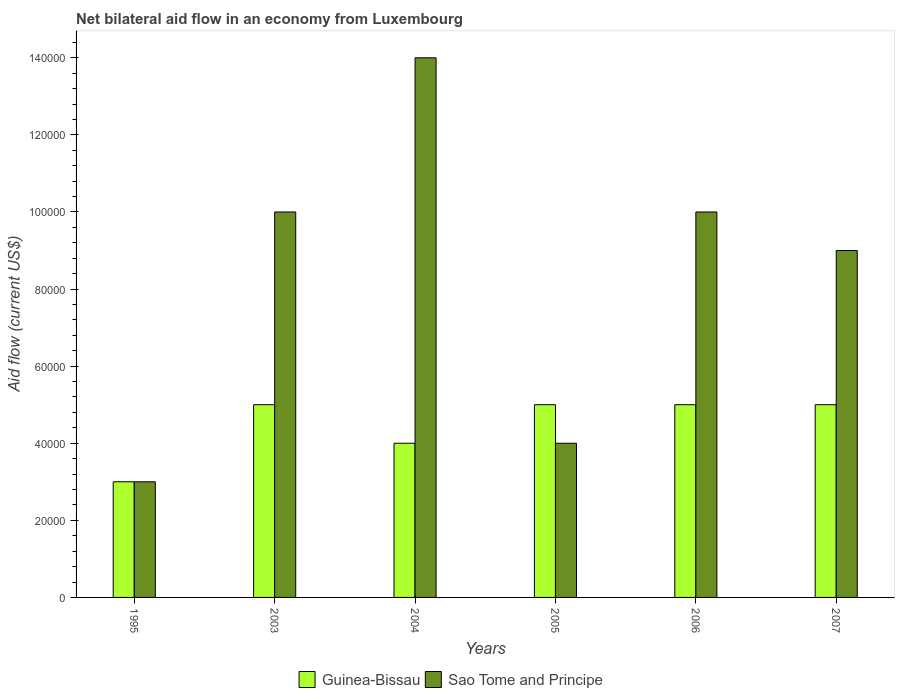How many different coloured bars are there?
Ensure brevity in your answer.  2. How many groups of bars are there?
Provide a short and direct response. 6. Are the number of bars per tick equal to the number of legend labels?
Provide a short and direct response. Yes. Are the number of bars on each tick of the X-axis equal?
Make the answer very short. Yes. How many bars are there on the 4th tick from the left?
Make the answer very short. 2. How many bars are there on the 6th tick from the right?
Give a very brief answer. 2. In how many cases, is the number of bars for a given year not equal to the number of legend labels?
Offer a terse response. 0. Across all years, what is the minimum net bilateral aid flow in Sao Tome and Principe?
Keep it short and to the point. 3.00e+04. In which year was the net bilateral aid flow in Guinea-Bissau maximum?
Provide a short and direct response. 2003. In which year was the net bilateral aid flow in Sao Tome and Principe minimum?
Give a very brief answer. 1995. What is the total net bilateral aid flow in Sao Tome and Principe in the graph?
Keep it short and to the point. 5.00e+05. What is the average net bilateral aid flow in Guinea-Bissau per year?
Your answer should be very brief. 4.50e+04. In how many years, is the net bilateral aid flow in Guinea-Bissau greater than 124000 US$?
Make the answer very short. 0. What is the ratio of the net bilateral aid flow in Guinea-Bissau in 2004 to that in 2006?
Keep it short and to the point. 0.8. What is the difference between the highest and the second highest net bilateral aid flow in Guinea-Bissau?
Offer a very short reply. 0. What does the 1st bar from the left in 2005 represents?
Make the answer very short. Guinea-Bissau. What does the 2nd bar from the right in 2003 represents?
Provide a succinct answer. Guinea-Bissau. How many bars are there?
Keep it short and to the point. 12. Are all the bars in the graph horizontal?
Provide a succinct answer. No. What is the difference between two consecutive major ticks on the Y-axis?
Give a very brief answer. 2.00e+04. Where does the legend appear in the graph?
Your answer should be compact. Bottom center. How many legend labels are there?
Provide a succinct answer. 2. What is the title of the graph?
Your answer should be compact. Net bilateral aid flow in an economy from Luxembourg. What is the Aid flow (current US$) of Guinea-Bissau in 2003?
Give a very brief answer. 5.00e+04. What is the Aid flow (current US$) of Guinea-Bissau in 2004?
Your response must be concise. 4.00e+04. What is the Aid flow (current US$) in Guinea-Bissau in 2006?
Provide a short and direct response. 5.00e+04. What is the Aid flow (current US$) of Sao Tome and Principe in 2006?
Provide a short and direct response. 1.00e+05. What is the difference between the Aid flow (current US$) in Guinea-Bissau in 1995 and that in 2003?
Provide a short and direct response. -2.00e+04. What is the difference between the Aid flow (current US$) in Guinea-Bissau in 1995 and that in 2004?
Offer a very short reply. -10000. What is the difference between the Aid flow (current US$) in Guinea-Bissau in 1995 and that in 2005?
Offer a very short reply. -2.00e+04. What is the difference between the Aid flow (current US$) in Sao Tome and Principe in 1995 and that in 2005?
Provide a succinct answer. -10000. What is the difference between the Aid flow (current US$) of Guinea-Bissau in 1995 and that in 2006?
Provide a short and direct response. -2.00e+04. What is the difference between the Aid flow (current US$) of Sao Tome and Principe in 2003 and that in 2004?
Make the answer very short. -4.00e+04. What is the difference between the Aid flow (current US$) in Sao Tome and Principe in 2003 and that in 2006?
Offer a terse response. 0. What is the difference between the Aid flow (current US$) in Guinea-Bissau in 2003 and that in 2007?
Provide a short and direct response. 0. What is the difference between the Aid flow (current US$) of Sao Tome and Principe in 2003 and that in 2007?
Ensure brevity in your answer.  10000. What is the difference between the Aid flow (current US$) of Guinea-Bissau in 2004 and that in 2006?
Provide a short and direct response. -10000. What is the difference between the Aid flow (current US$) of Sao Tome and Principe in 2004 and that in 2006?
Offer a very short reply. 4.00e+04. What is the difference between the Aid flow (current US$) of Sao Tome and Principe in 2004 and that in 2007?
Your answer should be very brief. 5.00e+04. What is the difference between the Aid flow (current US$) of Sao Tome and Principe in 2005 and that in 2006?
Provide a short and direct response. -6.00e+04. What is the difference between the Aid flow (current US$) of Sao Tome and Principe in 2005 and that in 2007?
Keep it short and to the point. -5.00e+04. What is the difference between the Aid flow (current US$) of Guinea-Bissau in 2006 and that in 2007?
Offer a terse response. 0. What is the difference between the Aid flow (current US$) in Guinea-Bissau in 1995 and the Aid flow (current US$) in Sao Tome and Principe in 2003?
Offer a terse response. -7.00e+04. What is the difference between the Aid flow (current US$) of Guinea-Bissau in 1995 and the Aid flow (current US$) of Sao Tome and Principe in 2004?
Ensure brevity in your answer.  -1.10e+05. What is the difference between the Aid flow (current US$) of Guinea-Bissau in 1995 and the Aid flow (current US$) of Sao Tome and Principe in 2005?
Your answer should be very brief. -10000. What is the difference between the Aid flow (current US$) in Guinea-Bissau in 1995 and the Aid flow (current US$) in Sao Tome and Principe in 2006?
Your answer should be very brief. -7.00e+04. What is the difference between the Aid flow (current US$) in Guinea-Bissau in 2003 and the Aid flow (current US$) in Sao Tome and Principe in 2004?
Keep it short and to the point. -9.00e+04. What is the difference between the Aid flow (current US$) of Guinea-Bissau in 2003 and the Aid flow (current US$) of Sao Tome and Principe in 2007?
Ensure brevity in your answer.  -4.00e+04. What is the difference between the Aid flow (current US$) of Guinea-Bissau in 2004 and the Aid flow (current US$) of Sao Tome and Principe in 2005?
Your answer should be very brief. 0. What is the difference between the Aid flow (current US$) in Guinea-Bissau in 2006 and the Aid flow (current US$) in Sao Tome and Principe in 2007?
Make the answer very short. -4.00e+04. What is the average Aid flow (current US$) in Guinea-Bissau per year?
Your answer should be compact. 4.50e+04. What is the average Aid flow (current US$) of Sao Tome and Principe per year?
Make the answer very short. 8.33e+04. In the year 1995, what is the difference between the Aid flow (current US$) in Guinea-Bissau and Aid flow (current US$) in Sao Tome and Principe?
Provide a short and direct response. 0. In the year 2003, what is the difference between the Aid flow (current US$) of Guinea-Bissau and Aid flow (current US$) of Sao Tome and Principe?
Provide a short and direct response. -5.00e+04. In the year 2004, what is the difference between the Aid flow (current US$) in Guinea-Bissau and Aid flow (current US$) in Sao Tome and Principe?
Your response must be concise. -1.00e+05. In the year 2005, what is the difference between the Aid flow (current US$) in Guinea-Bissau and Aid flow (current US$) in Sao Tome and Principe?
Provide a short and direct response. 10000. In the year 2006, what is the difference between the Aid flow (current US$) of Guinea-Bissau and Aid flow (current US$) of Sao Tome and Principe?
Your answer should be very brief. -5.00e+04. What is the ratio of the Aid flow (current US$) of Guinea-Bissau in 1995 to that in 2003?
Keep it short and to the point. 0.6. What is the ratio of the Aid flow (current US$) in Sao Tome and Principe in 1995 to that in 2003?
Offer a very short reply. 0.3. What is the ratio of the Aid flow (current US$) of Guinea-Bissau in 1995 to that in 2004?
Make the answer very short. 0.75. What is the ratio of the Aid flow (current US$) in Sao Tome and Principe in 1995 to that in 2004?
Offer a terse response. 0.21. What is the ratio of the Aid flow (current US$) of Guinea-Bissau in 1995 to that in 2005?
Give a very brief answer. 0.6. What is the ratio of the Aid flow (current US$) of Sao Tome and Principe in 1995 to that in 2005?
Your answer should be compact. 0.75. What is the ratio of the Aid flow (current US$) in Sao Tome and Principe in 2003 to that in 2004?
Your response must be concise. 0.71. What is the ratio of the Aid flow (current US$) of Sao Tome and Principe in 2003 to that in 2005?
Your response must be concise. 2.5. What is the ratio of the Aid flow (current US$) of Guinea-Bissau in 2003 to that in 2006?
Give a very brief answer. 1. What is the ratio of the Aid flow (current US$) of Sao Tome and Principe in 2003 to that in 2006?
Offer a terse response. 1. What is the ratio of the Aid flow (current US$) in Guinea-Bissau in 2003 to that in 2007?
Ensure brevity in your answer.  1. What is the ratio of the Aid flow (current US$) of Sao Tome and Principe in 2003 to that in 2007?
Your answer should be very brief. 1.11. What is the ratio of the Aid flow (current US$) in Guinea-Bissau in 2004 to that in 2006?
Ensure brevity in your answer.  0.8. What is the ratio of the Aid flow (current US$) of Sao Tome and Principe in 2004 to that in 2006?
Ensure brevity in your answer.  1.4. What is the ratio of the Aid flow (current US$) in Sao Tome and Principe in 2004 to that in 2007?
Offer a very short reply. 1.56. What is the ratio of the Aid flow (current US$) of Guinea-Bissau in 2005 to that in 2007?
Provide a short and direct response. 1. What is the ratio of the Aid flow (current US$) in Sao Tome and Principe in 2005 to that in 2007?
Give a very brief answer. 0.44. What is the ratio of the Aid flow (current US$) in Guinea-Bissau in 2006 to that in 2007?
Give a very brief answer. 1. What is the ratio of the Aid flow (current US$) of Sao Tome and Principe in 2006 to that in 2007?
Offer a very short reply. 1.11. What is the difference between the highest and the second highest Aid flow (current US$) of Guinea-Bissau?
Keep it short and to the point. 0. What is the difference between the highest and the lowest Aid flow (current US$) in Sao Tome and Principe?
Ensure brevity in your answer.  1.10e+05. 